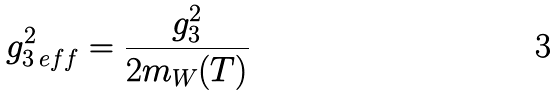<formula> <loc_0><loc_0><loc_500><loc_500>g _ { 3 \, e f f } ^ { 2 } = \frac { g _ { 3 } ^ { 2 } } { 2 m _ { W } ( T ) }</formula> 